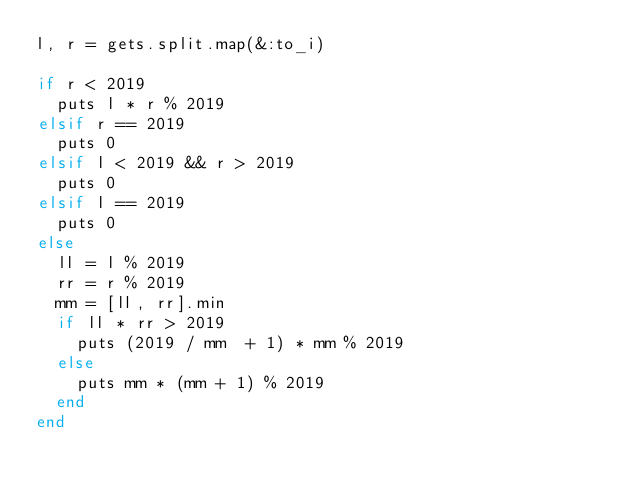<code> <loc_0><loc_0><loc_500><loc_500><_Ruby_>l, r = gets.split.map(&:to_i)

if r < 2019
  puts l * r % 2019
elsif r == 2019
  puts 0
elsif l < 2019 && r > 2019
  puts 0
elsif l == 2019
  puts 0
else
  ll = l % 2019
  rr = r % 2019
  mm = [ll, rr].min
  if ll * rr > 2019
    puts (2019 / mm  + 1) * mm % 2019
  else
    puts mm * (mm + 1) % 2019
  end
end</code> 